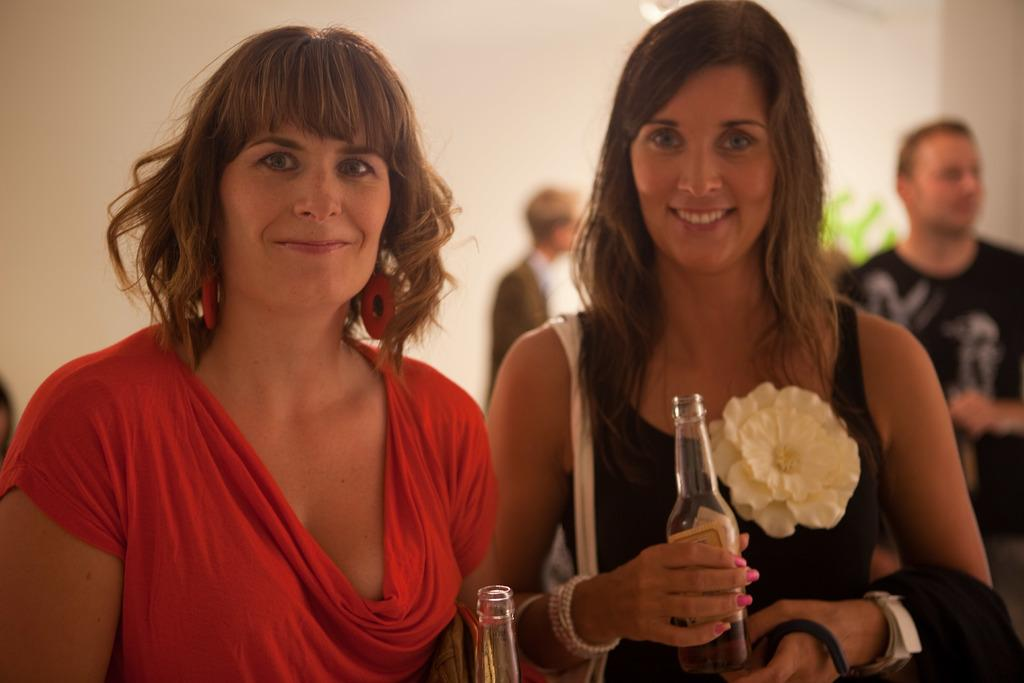How many people are present in the image? There are two women in the image. What are the women doing in the image? The women are standing beside each other and holding beer bottles. Can you describe the people in the background of the image? There are two men in the background of the image. What color is the friend's shirt in the image? There is no friend mentioned in the image, and no information about the color of anyone's shirt is provided. What type of liquid is being consumed by the women in the image? The women are holding beer bottles, so they are likely consuming beer, which is a type of liquid. 